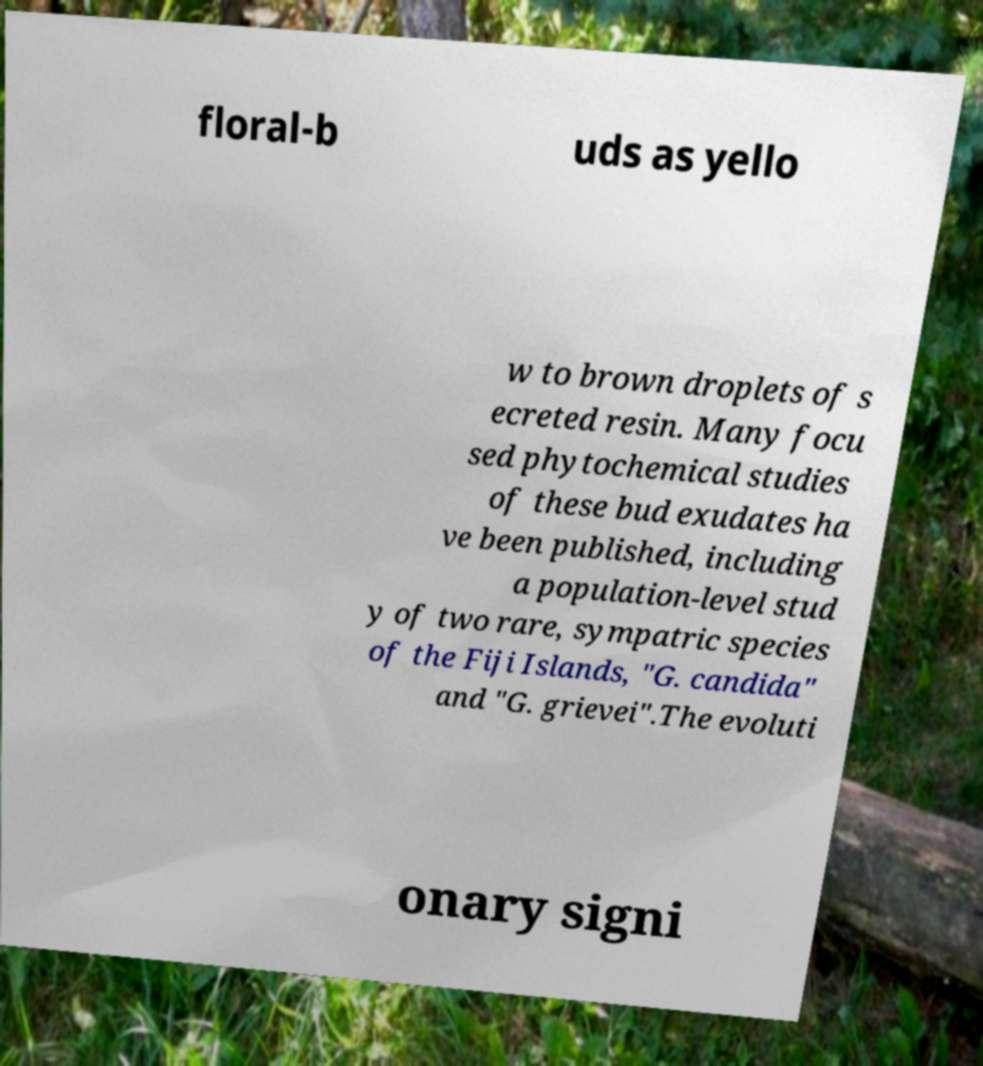Can you accurately transcribe the text from the provided image for me? floral-b uds as yello w to brown droplets of s ecreted resin. Many focu sed phytochemical studies of these bud exudates ha ve been published, including a population-level stud y of two rare, sympatric species of the Fiji Islands, "G. candida" and "G. grievei".The evoluti onary signi 